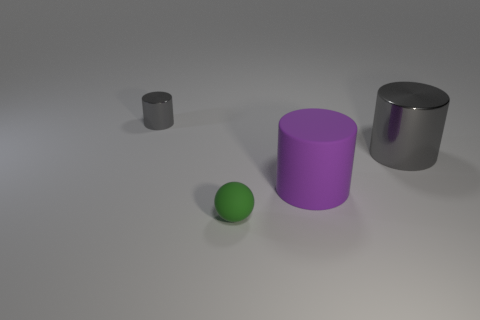What number of tiny green rubber objects are behind the cylinder in front of the gray cylinder that is right of the purple matte object?
Your answer should be very brief. 0. Do the big purple thing and the small thing that is on the left side of the tiny green rubber sphere have the same shape?
Make the answer very short. Yes. What is the color of the thing that is both right of the tiny matte ball and in front of the big gray cylinder?
Offer a very short reply. Purple. What material is the gray object on the left side of the big cylinder that is on the left side of the large gray shiny cylinder that is behind the small rubber object?
Ensure brevity in your answer.  Metal. What is the tiny green sphere made of?
Give a very brief answer. Rubber. There is a matte thing that is the same shape as the big gray metal object; what is its size?
Your response must be concise. Large. Is the color of the large rubber object the same as the large metal object?
Make the answer very short. No. How many other objects are there of the same material as the big purple object?
Your response must be concise. 1. Are there an equal number of balls that are to the right of the tiny ball and big purple shiny cubes?
Give a very brief answer. Yes. There is a matte thing that is left of the purple cylinder; does it have the same size as the tiny metallic object?
Provide a short and direct response. Yes. 